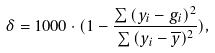Convert formula to latex. <formula><loc_0><loc_0><loc_500><loc_500>\delta = 1 0 0 0 \cdot ( 1 - \frac { \sum { ( y _ { i } - g _ { i } ) ^ { 2 } } } { \sum { ( y _ { i } - \overline { y } ) ^ { 2 } } } ) ,</formula> 